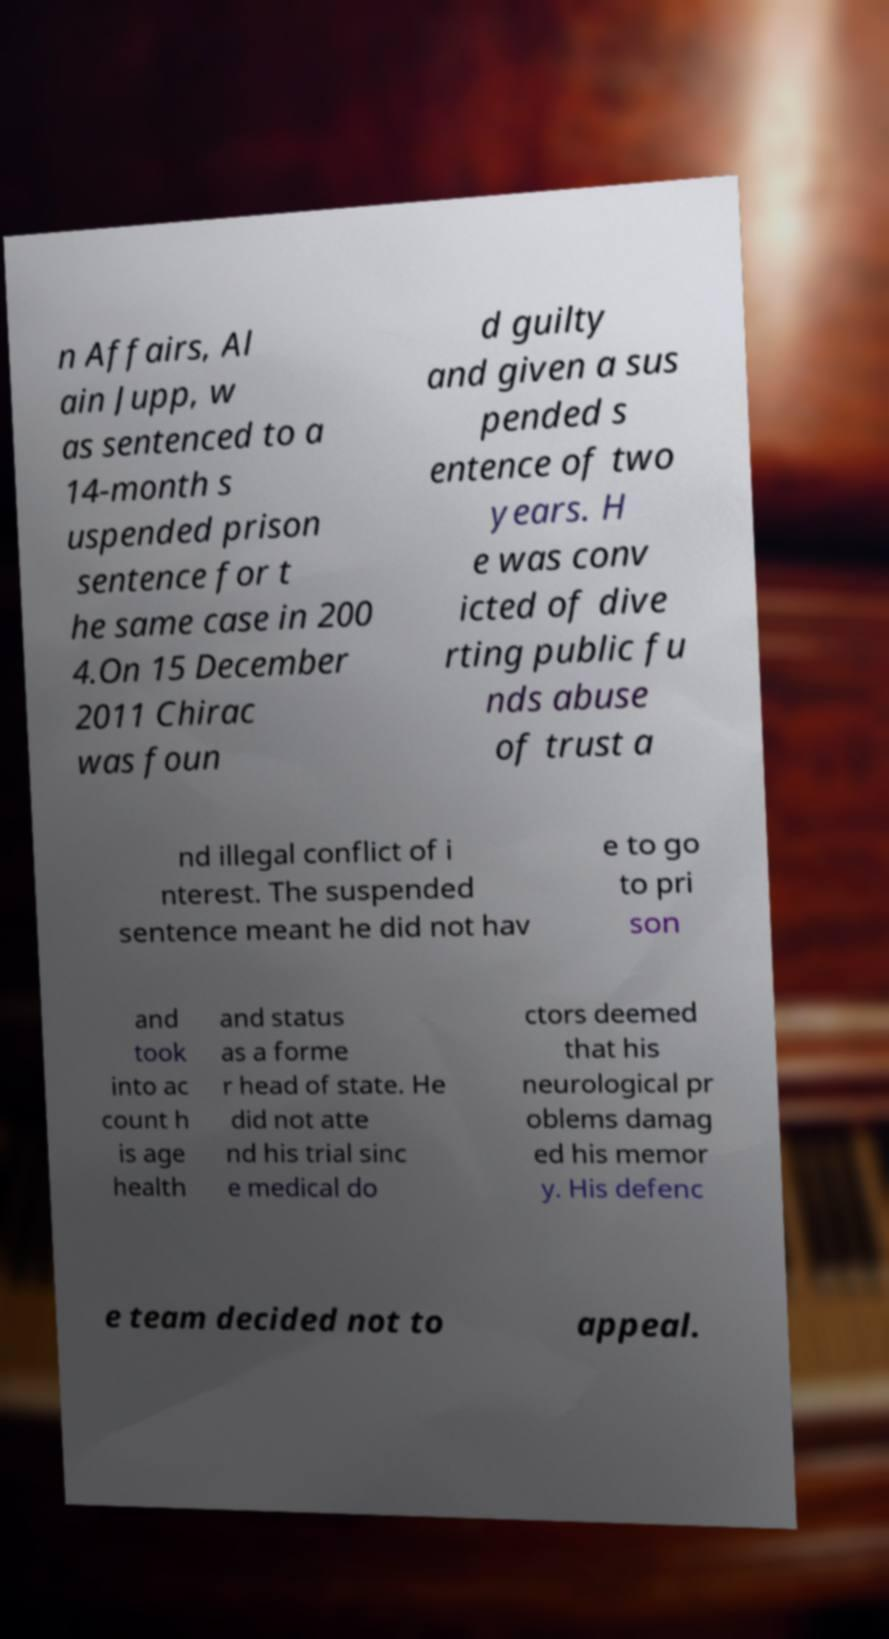There's text embedded in this image that I need extracted. Can you transcribe it verbatim? n Affairs, Al ain Jupp, w as sentenced to a 14-month s uspended prison sentence for t he same case in 200 4.On 15 December 2011 Chirac was foun d guilty and given a sus pended s entence of two years. H e was conv icted of dive rting public fu nds abuse of trust a nd illegal conflict of i nterest. The suspended sentence meant he did not hav e to go to pri son and took into ac count h is age health and status as a forme r head of state. He did not atte nd his trial sinc e medical do ctors deemed that his neurological pr oblems damag ed his memor y. His defenc e team decided not to appeal. 